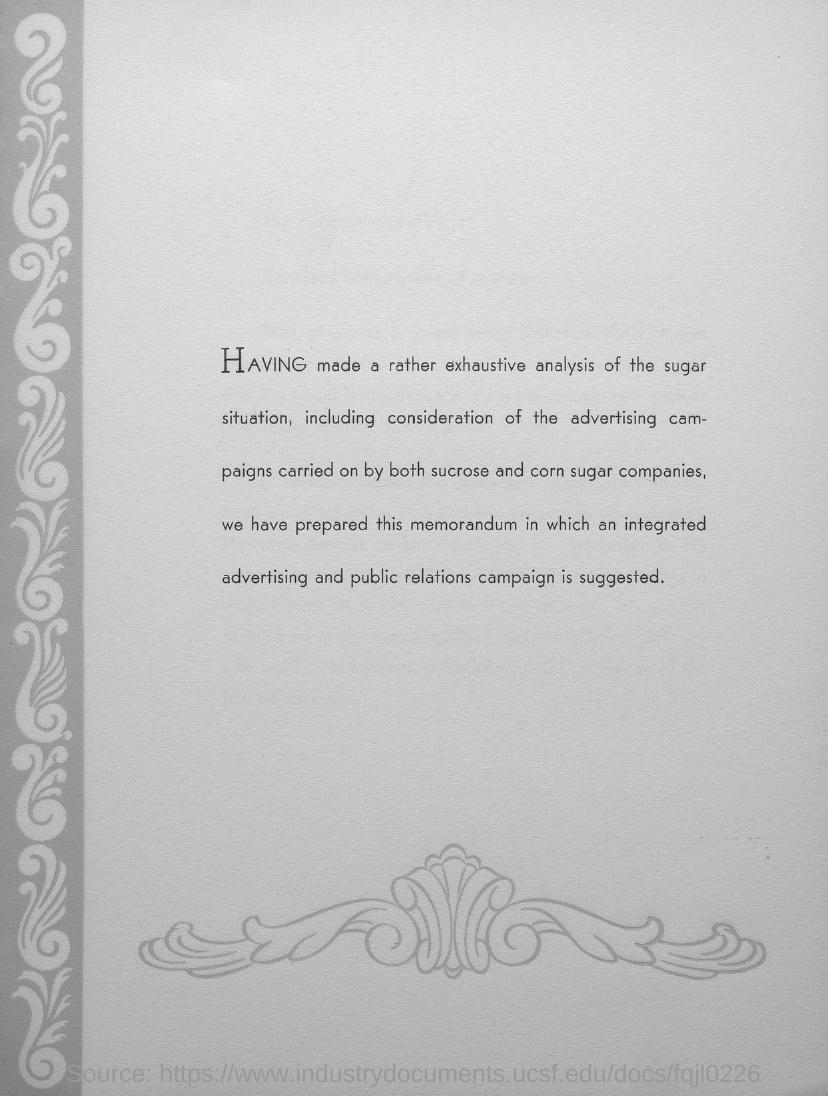What is the word that is written in capital letters?
Your response must be concise. HAVING. 